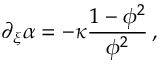<formula> <loc_0><loc_0><loc_500><loc_500>\partial _ { \xi } \alpha = - \kappa \frac { 1 - \phi ^ { 2 } } { \phi ^ { 2 } } \, ,</formula> 